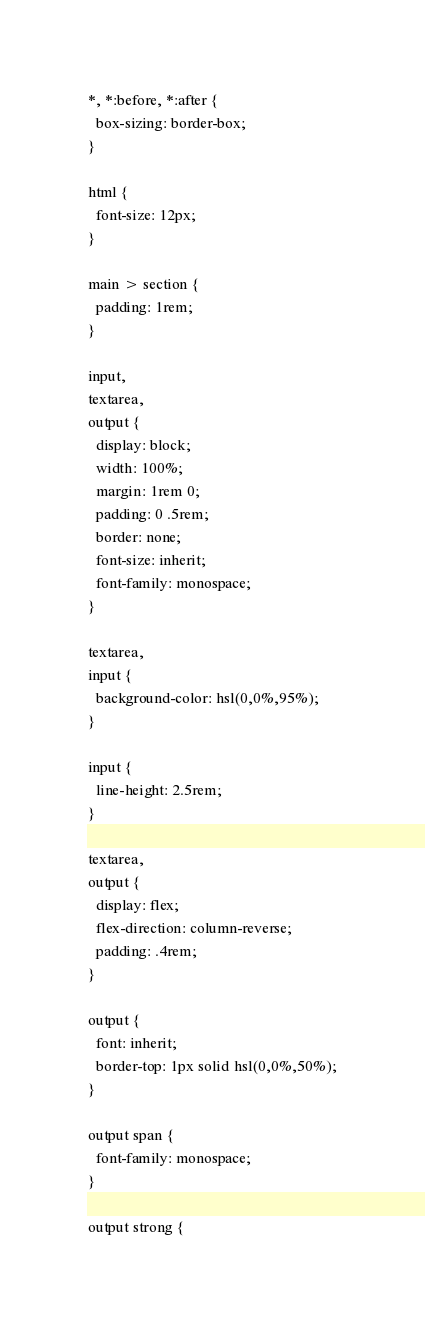Convert code to text. <code><loc_0><loc_0><loc_500><loc_500><_CSS_>*, *:before, *:after {
  box-sizing: border-box;
}

html {
  font-size: 12px;
}

main > section {
  padding: 1rem;
}

input,
textarea,
output {
  display: block;
  width: 100%;
  margin: 1rem 0;
  padding: 0 .5rem;
  border: none;
  font-size: inherit;
  font-family: monospace;
}

textarea,
input {
  background-color: hsl(0,0%,95%);
}

input {
  line-height: 2.5rem;
}

textarea,
output {
  display: flex;
  flex-direction: column-reverse;
  padding: .4rem;
}

output {
  font: inherit;
  border-top: 1px solid hsl(0,0%,50%);
}

output span {
  font-family: monospace;
}

output strong {</code> 